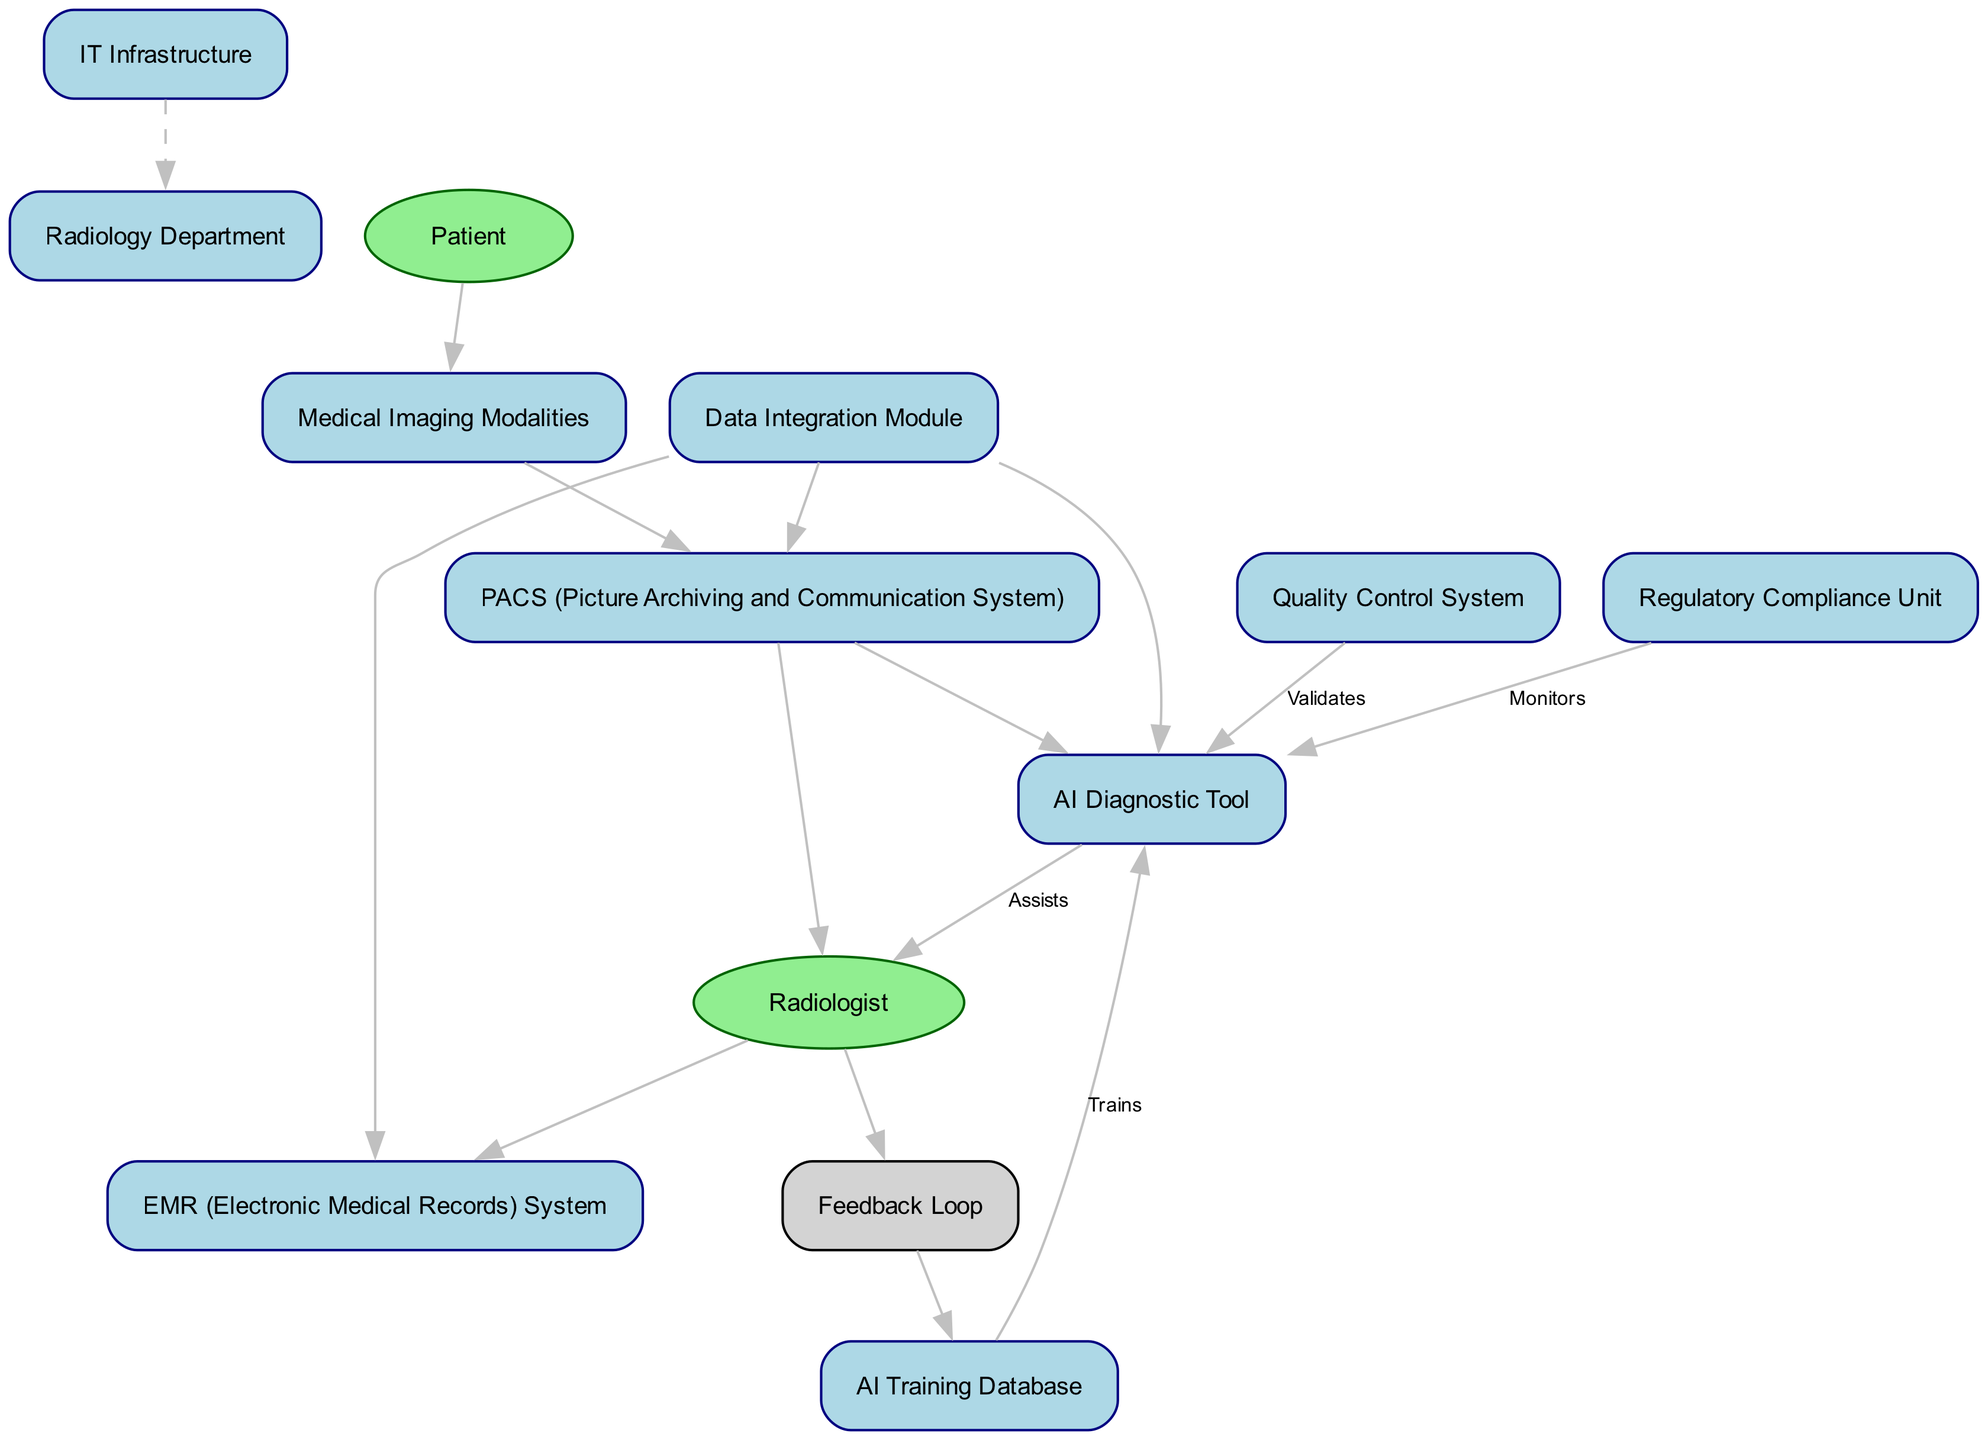What is the primary department depicted in the diagram? The block labeled "Radiology Department" clearly represents the essential location where radiological examinations take place. Therefore, the answer is based entirely on identifying this block from the provided diagram.
Answer: Radiology Department How many blocks are present in the diagram? Counting the number of blocks listed in the elements section of the diagram, we identify a total of 11 blocks which include: Radiology Department, PACS, AI Diagnostic Tool, EMR, Medical Imaging Modalities, AI Training Database, Data Integration Module, Quality Control System, Regulatory Compliance Unit, and IT Infrastructure.
Answer: 11 What is the role of the AI Diagnostic Tool in relation to the Radiologist? The diagram indicates a direct connection where the AI Diagnostic Tool assists the Radiologist. This relationship is explicitly marked in a directional line with the label "Assists," outlining the tool's supportive function in diagnostics.
Answer: Assists Which system is responsible for ensuring the accuracy of AI diagnostics? The block named "Quality Control System" explicitly states that it verifies and ensures the reliability of AI-driven diagnostics, thus answering the query about assurance mechanisms in place.
Answer: Quality Control System What feedback mechanism is shown in the diagram for improving AI capabilities? The "Feedback Loop" is highlighted in the structure, which indicates that there is a process where the Radiologist provides feedback, ultimately refining the capabilities of the AI Diagnostic Tool. This illustrates the continuous improvement cycle involved.
Answer: Feedback Loop In what way does the Data Integration Module relate to the different systems? The connections from the Data Integration Module to PACS, EMR, and the AI Diagnostic Tool indicate that this module facilitates the seamless integration of patient data across these systems, enabling cohesive functioning among them.
Answer: Seamless integration Which unit is tasked with regulatory compliance for AI tools? The diagram clearly illustrates that the "Regulatory Compliance Unit" is responsible for ensuring that all AI diagnostic tools conform to required medical regulations and standards, as depicted in its connection to the AI Diagnostic Tool.
Answer: Regulatory Compliance Unit How does the IT Infrastructure support the Radiology Department? The IT Infrastructure is represented as supporting the Radiology Department, implying that underlying technology is necessary for the operational and integration aspects of the AI-driven diagnostic tools used in that department.
Answer: Supports operation What is used to train the AI Diagnostic Tool? The block labeled "AI Training Database" in the diagram specifically indicates that it contains the labeled data necessary for the training of the AI Diagnostic Tool, establishing the data source for learning algorithms.
Answer: AI Training Database 